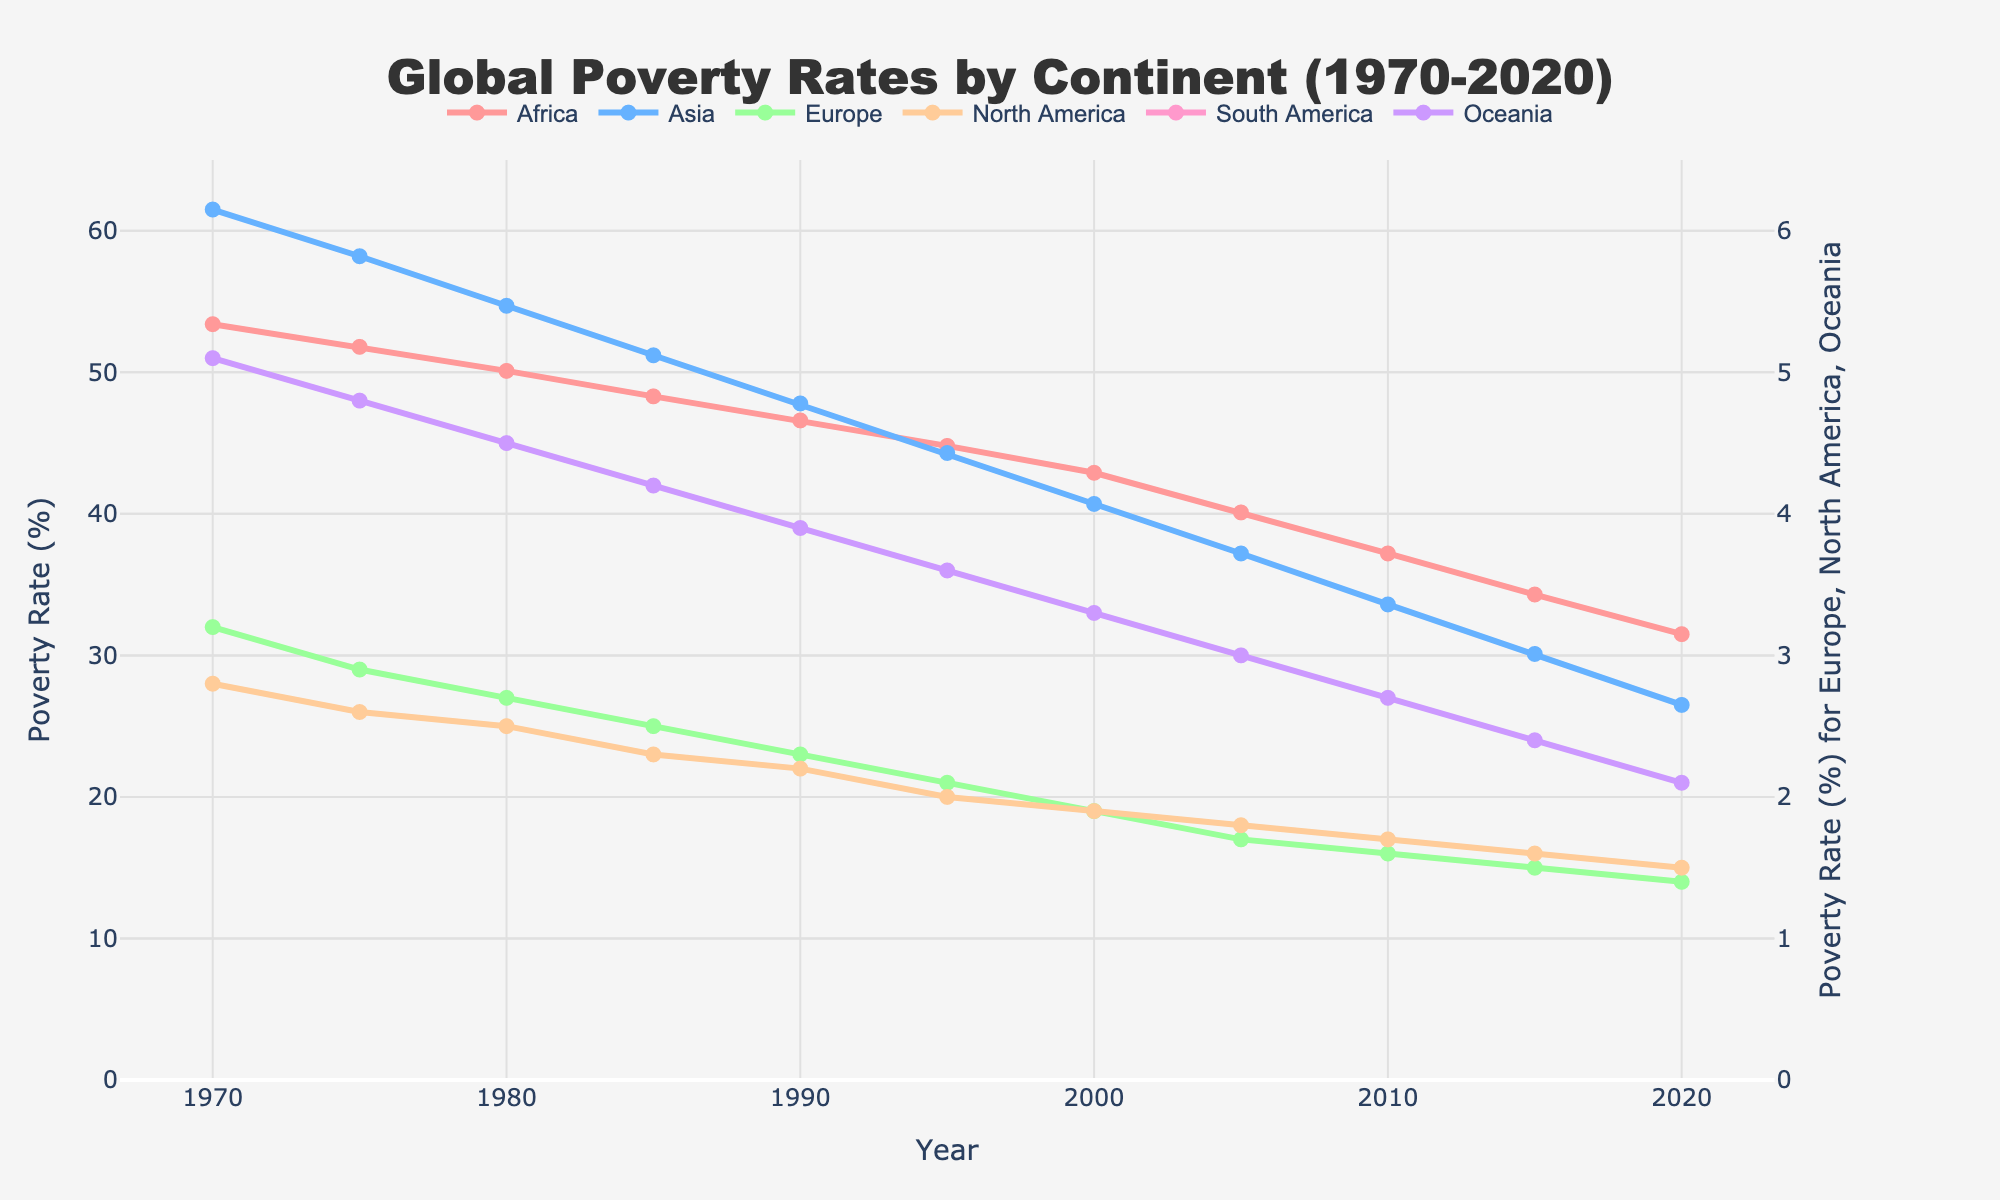What is the general trend of poverty rates in Africa from 1970 to 2020? The poverty rate in Africa decreases over time from 53.4% in 1970 to 31.5% in 2020, consistently showing a downward trend across the years.
Answer: Decreasing Which continent had the highest poverty rate in 1980? By looking at the data points for each continent in 1980, Asia had the highest poverty rate of 54.7%.
Answer: Asia By how many percentage points did the poverty rate in Asia decrease from 1970 to 2020? The poverty rate in Asia in 1970 was 61.5%, and it decreased to 26.5% in 2020. So, the decrease is 61.5 - 26.5 = 35.
Answer: 35 Compare the poverty rates of Europe and South America in 1995. Which one is higher and by how much? In 1995, Europe's poverty rate was 2.1%, and South America's was 15.9%. The difference is 15.9 - 2.1 = 13.8, with South America being higher.
Answer: South America by 13.8 What is the range of poverty rates for Oceania from 1970 to 2020? The range is calculated by subtracting the minimum value from the maximum value. The highest value is 5.1% in 1970 and the lowest is 2.1% in 2020. So, the range is 5.1 - 2.1 = 3.
Answer: 3 What is the average poverty rate in South America over the given years? Adding the poverty rates of South America over the 11 given years: 24.5 + 22.1 + 19.8 + 18.6 + 17.3 + 15.9 + 14.6 + 13.2 + 11.9 + 10.5 + 9.2 = 177.6. Dividing by 11, the average is 177.6 / 11 = 16.14.
Answer: 16.14 Did Oceania always have a lower poverty rate than North America? Comparing the poverty rates for Oceania and North America for each year, Oceania's rates were always higher than North America's, except in the years when their rates are tied or slightly overlap.
Answer: No What year did Europe reach its lowest poverty rate, and what was it? Europe reached its lowest poverty rate of 1.4% in 2020, as shown in the data.
Answer: 2020, 1.4% Which continents show a poverty rate below 5% in 2020? Looking at the data for 2020, Europe, North America, and Oceania have poverty rates below 5%.
Answer: Europe, North America, Oceania 